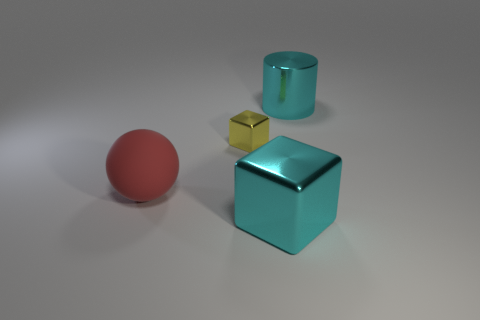There is a thing that is behind the block that is behind the metallic cube that is on the right side of the tiny yellow metallic cube; what shape is it?
Ensure brevity in your answer.  Cylinder. Is there anything else that is made of the same material as the small yellow cube?
Your answer should be compact. Yes. What size is the other shiny object that is the same shape as the yellow object?
Your answer should be compact. Large. The metallic object that is both behind the large red sphere and to the left of the large cyan cylinder is what color?
Your response must be concise. Yellow. Is the large cyan block made of the same material as the tiny yellow object in front of the cyan cylinder?
Offer a terse response. Yes. Are there fewer metallic cubes behind the red thing than tiny gray balls?
Keep it short and to the point. No. How many other objects are the same shape as the yellow thing?
Make the answer very short. 1. Are there any other things of the same color as the ball?
Give a very brief answer. No. Do the small thing and the large metallic thing in front of the red object have the same color?
Your answer should be very brief. No. How many other things are the same size as the yellow metallic thing?
Provide a short and direct response. 0. 